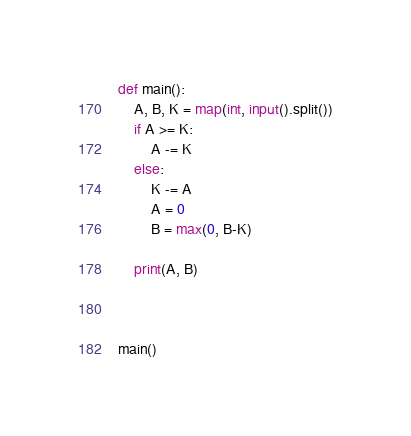Convert code to text. <code><loc_0><loc_0><loc_500><loc_500><_Python_>def main():
    A, B, K = map(int, input().split())
    if A >= K:
        A -= K
    else:
        K -= A
        A = 0
        B = max(0, B-K)

    print(A, B)

    

main()</code> 